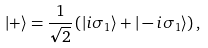<formula> <loc_0><loc_0><loc_500><loc_500>| + \rangle = { \frac { 1 } { \sqrt { 2 } } } \left ( | i \sigma _ { 1 } \rangle + | - i \sigma _ { 1 } \rangle \right ) ,</formula> 